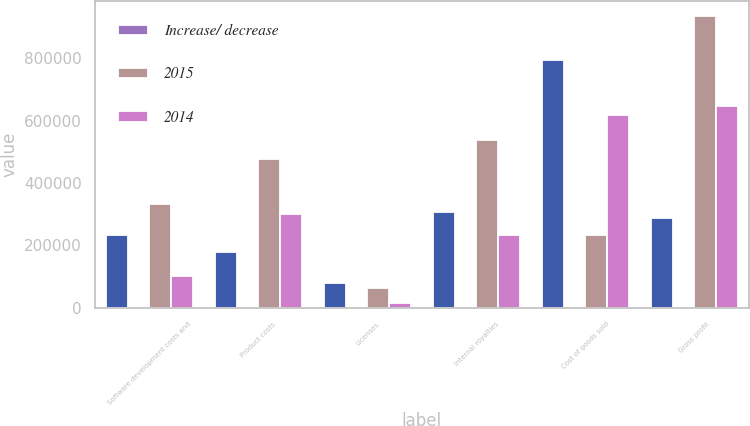Convert chart to OTSL. <chart><loc_0><loc_0><loc_500><loc_500><stacked_bar_chart><ecel><fcel>Software development costs and<fcel>Product costs<fcel>Licenses<fcel>Internal royalties<fcel>Cost of goods sold<fcel>Gross profit<nl><fcel>nan<fcel>231615<fcel>178810<fcel>77725<fcel>306717<fcel>794867<fcel>288071<nl><fcel>Increase/ decrease<fcel>21.4<fcel>16.5<fcel>7.2<fcel>28.3<fcel>73.4<fcel>26.6<nl><fcel>2015<fcel>333450<fcel>477861<fcel>64412<fcel>538604<fcel>231615<fcel>936241<nl><fcel>2014<fcel>101835<fcel>299051<fcel>13313<fcel>231887<fcel>619460<fcel>648170<nl></chart> 